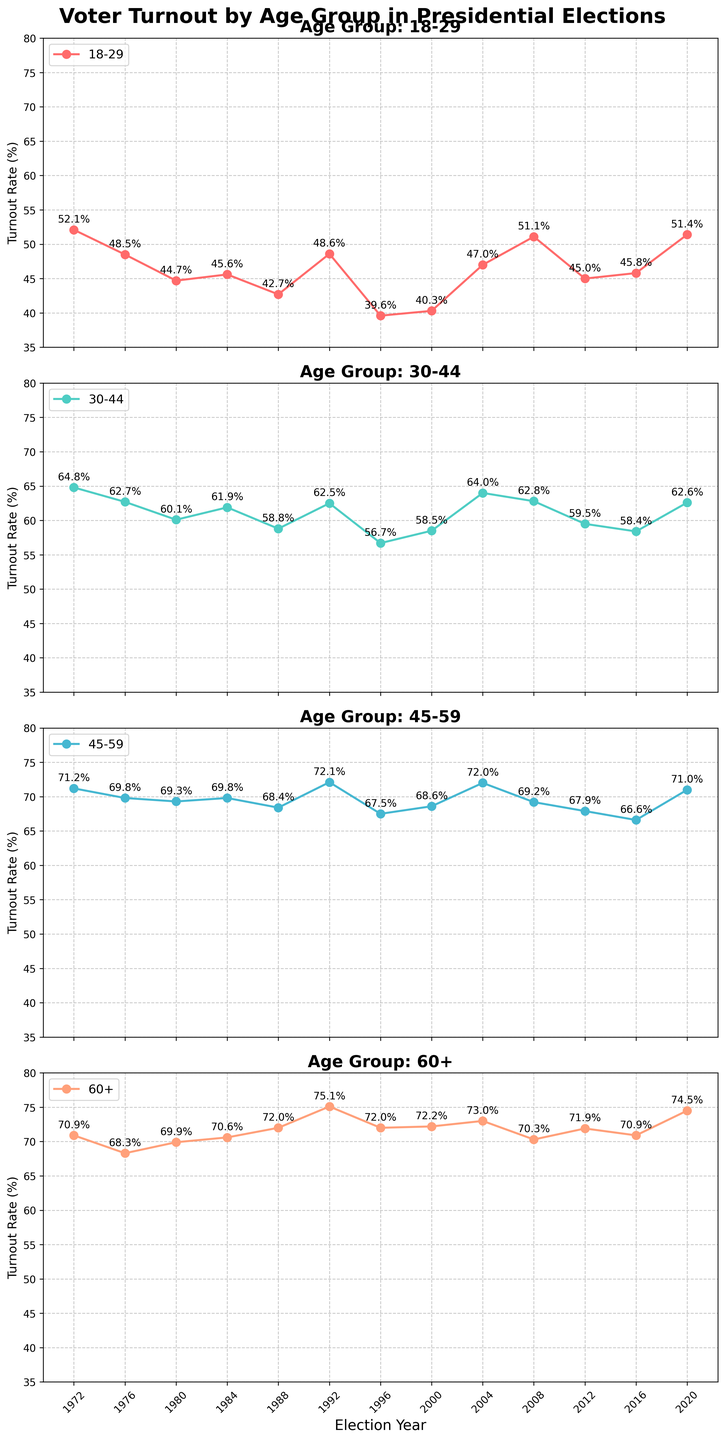What's the voter turnout rate for the 18-29 age group in 1972? The 1972 subplot for the 18-29 age group shows 52.1%.
Answer: 52.1% Which age group had the highest turnout in 1988, and what was the percentage? In the subplot for 1988, the age group 60+ had the highest turnout at 72%.
Answer: 60+ with 72% How did the turnout rate for the 18-29 age group change from 1996 to 2004? The turnout for the 18-29 age group was 39.6% in 1996 and increased to 47% in 2004.
Answer: Increased by 7.4% Compare the voter turnout rates for the 30-44 age group in 2008 and 2012. The 30-44 age group had a turnout rate of 62.8% in 2008 and 59.5% in 2012.
Answer: Decreased by 3.3% What was the average turnout rate for the 45-59 age group in 2020? Only one data point for 2020, which is 71.0%, so the average is 71.0%.
Answer: 71.0% Which year showed the lowest turnout rate for the 60+ age group, and what was the percentage? The subplot for the 60+ age group indicates that the lowest turnout was in 1980 at 69.9%.
Answer: 1980 with 69.9% Between which two consecutive elections did the 45-59 age group's turnout rate show the largest increase? From 2000 (68.6%) to 2004 (72.0%) shows an increase of 3.4%, which is the largest increase between consecutive elections for the 45-59 age group.
Answer: 2000 to 2004 What is the difference in the turnout rate between the 18-29 and 60+ age groups in 1976? In 1976, the turnout was 48.5% for 18-29 and 68.3% for 60+. The difference is 68.3% - 48.5% = 19.8%.
Answer: 19.8% In which election year did the 30-44 age group have the closest turnout rate to the 18-29 age group, and what were the rates? In 1996, the 30-44 age group had a turnout of 56.7%, and the 18-29 age group had a turnout of 39.6%, which is the closest gap among all years.
Answer: 1996: 56.7% (30-44) and 39.6% (18-29) Identify the trend of voter turnout for the 60+ age group from 2000 to 2020. From 2000 to 2020, the voter turnout for the 60+ age group shows a generally increasing trend, starting at 72.2% in 2000 and ending at 74.5% in 2020.
Answer: Increasing trend 